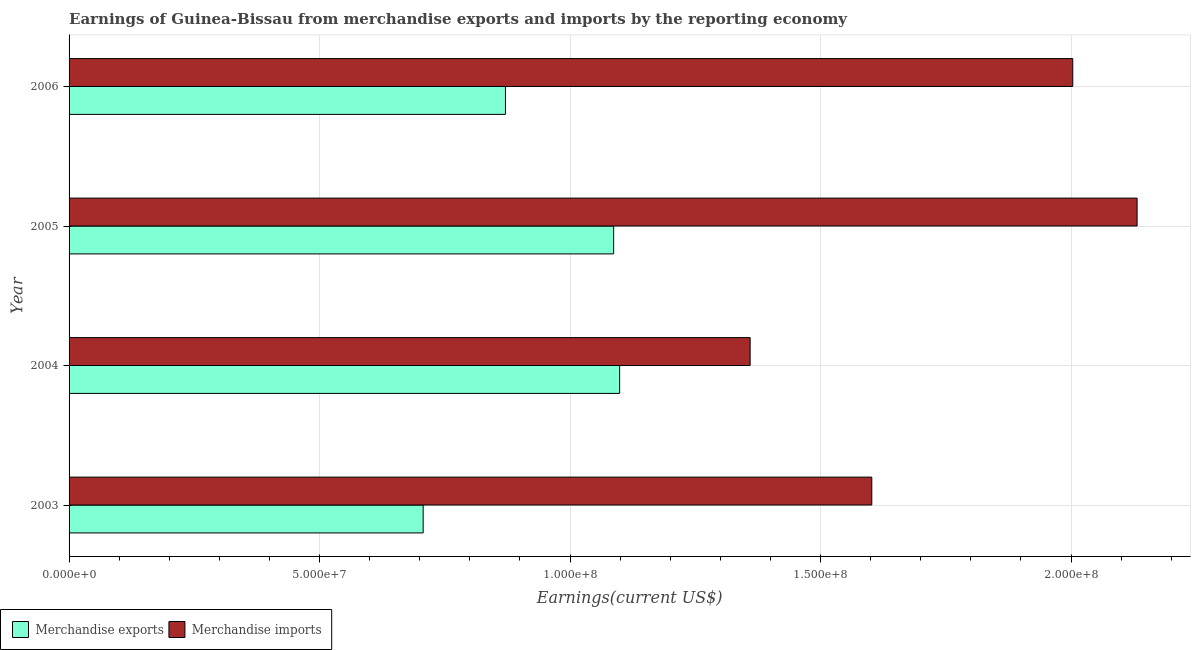How many different coloured bars are there?
Your response must be concise. 2. How many groups of bars are there?
Ensure brevity in your answer.  4. Are the number of bars per tick equal to the number of legend labels?
Ensure brevity in your answer.  Yes. How many bars are there on the 3rd tick from the bottom?
Ensure brevity in your answer.  2. What is the label of the 2nd group of bars from the top?
Ensure brevity in your answer.  2005. What is the earnings from merchandise imports in 2005?
Provide a short and direct response. 2.13e+08. Across all years, what is the maximum earnings from merchandise imports?
Your answer should be compact. 2.13e+08. Across all years, what is the minimum earnings from merchandise imports?
Your response must be concise. 1.36e+08. In which year was the earnings from merchandise imports minimum?
Ensure brevity in your answer.  2004. What is the total earnings from merchandise imports in the graph?
Provide a succinct answer. 7.10e+08. What is the difference between the earnings from merchandise exports in 2004 and that in 2005?
Give a very brief answer. 1.20e+06. What is the difference between the earnings from merchandise exports in 2004 and the earnings from merchandise imports in 2005?
Give a very brief answer. -1.03e+08. What is the average earnings from merchandise imports per year?
Your response must be concise. 1.77e+08. In the year 2005, what is the difference between the earnings from merchandise imports and earnings from merchandise exports?
Provide a succinct answer. 1.04e+08. Is the earnings from merchandise exports in 2005 less than that in 2006?
Your answer should be very brief. No. What is the difference between the highest and the second highest earnings from merchandise imports?
Your response must be concise. 1.28e+07. What is the difference between the highest and the lowest earnings from merchandise exports?
Your answer should be compact. 3.92e+07. Is the sum of the earnings from merchandise imports in 2003 and 2005 greater than the maximum earnings from merchandise exports across all years?
Your answer should be very brief. Yes. What does the 2nd bar from the bottom in 2003 represents?
Your answer should be compact. Merchandise imports. How many bars are there?
Your answer should be very brief. 8. How many years are there in the graph?
Your answer should be very brief. 4. Are the values on the major ticks of X-axis written in scientific E-notation?
Provide a succinct answer. Yes. Does the graph contain any zero values?
Keep it short and to the point. No. Does the graph contain grids?
Your answer should be compact. Yes. How are the legend labels stacked?
Make the answer very short. Horizontal. What is the title of the graph?
Make the answer very short. Earnings of Guinea-Bissau from merchandise exports and imports by the reporting economy. Does "Non-solid fuel" appear as one of the legend labels in the graph?
Provide a short and direct response. No. What is the label or title of the X-axis?
Keep it short and to the point. Earnings(current US$). What is the Earnings(current US$) in Merchandise exports in 2003?
Provide a succinct answer. 7.07e+07. What is the Earnings(current US$) in Merchandise imports in 2003?
Your response must be concise. 1.60e+08. What is the Earnings(current US$) of Merchandise exports in 2004?
Your answer should be compact. 1.10e+08. What is the Earnings(current US$) in Merchandise imports in 2004?
Offer a terse response. 1.36e+08. What is the Earnings(current US$) of Merchandise exports in 2005?
Offer a terse response. 1.09e+08. What is the Earnings(current US$) in Merchandise imports in 2005?
Offer a very short reply. 2.13e+08. What is the Earnings(current US$) of Merchandise exports in 2006?
Your answer should be very brief. 8.71e+07. What is the Earnings(current US$) in Merchandise imports in 2006?
Offer a very short reply. 2.00e+08. Across all years, what is the maximum Earnings(current US$) of Merchandise exports?
Your response must be concise. 1.10e+08. Across all years, what is the maximum Earnings(current US$) of Merchandise imports?
Your answer should be very brief. 2.13e+08. Across all years, what is the minimum Earnings(current US$) in Merchandise exports?
Ensure brevity in your answer.  7.07e+07. Across all years, what is the minimum Earnings(current US$) in Merchandise imports?
Provide a short and direct response. 1.36e+08. What is the total Earnings(current US$) in Merchandise exports in the graph?
Make the answer very short. 3.76e+08. What is the total Earnings(current US$) in Merchandise imports in the graph?
Give a very brief answer. 7.10e+08. What is the difference between the Earnings(current US$) in Merchandise exports in 2003 and that in 2004?
Offer a terse response. -3.92e+07. What is the difference between the Earnings(current US$) of Merchandise imports in 2003 and that in 2004?
Your answer should be very brief. 2.43e+07. What is the difference between the Earnings(current US$) of Merchandise exports in 2003 and that in 2005?
Make the answer very short. -3.80e+07. What is the difference between the Earnings(current US$) of Merchandise imports in 2003 and that in 2005?
Ensure brevity in your answer.  -5.30e+07. What is the difference between the Earnings(current US$) of Merchandise exports in 2003 and that in 2006?
Provide a succinct answer. -1.64e+07. What is the difference between the Earnings(current US$) in Merchandise imports in 2003 and that in 2006?
Provide a succinct answer. -4.01e+07. What is the difference between the Earnings(current US$) of Merchandise exports in 2004 and that in 2005?
Your response must be concise. 1.20e+06. What is the difference between the Earnings(current US$) of Merchandise imports in 2004 and that in 2005?
Ensure brevity in your answer.  -7.72e+07. What is the difference between the Earnings(current US$) of Merchandise exports in 2004 and that in 2006?
Give a very brief answer. 2.28e+07. What is the difference between the Earnings(current US$) of Merchandise imports in 2004 and that in 2006?
Keep it short and to the point. -6.44e+07. What is the difference between the Earnings(current US$) of Merchandise exports in 2005 and that in 2006?
Keep it short and to the point. 2.16e+07. What is the difference between the Earnings(current US$) in Merchandise imports in 2005 and that in 2006?
Offer a very short reply. 1.28e+07. What is the difference between the Earnings(current US$) of Merchandise exports in 2003 and the Earnings(current US$) of Merchandise imports in 2004?
Your response must be concise. -6.53e+07. What is the difference between the Earnings(current US$) in Merchandise exports in 2003 and the Earnings(current US$) in Merchandise imports in 2005?
Ensure brevity in your answer.  -1.43e+08. What is the difference between the Earnings(current US$) in Merchandise exports in 2003 and the Earnings(current US$) in Merchandise imports in 2006?
Your answer should be compact. -1.30e+08. What is the difference between the Earnings(current US$) of Merchandise exports in 2004 and the Earnings(current US$) of Merchandise imports in 2005?
Your answer should be very brief. -1.03e+08. What is the difference between the Earnings(current US$) in Merchandise exports in 2004 and the Earnings(current US$) in Merchandise imports in 2006?
Provide a short and direct response. -9.04e+07. What is the difference between the Earnings(current US$) of Merchandise exports in 2005 and the Earnings(current US$) of Merchandise imports in 2006?
Make the answer very short. -9.16e+07. What is the average Earnings(current US$) of Merchandise exports per year?
Provide a succinct answer. 9.41e+07. What is the average Earnings(current US$) of Merchandise imports per year?
Offer a very short reply. 1.77e+08. In the year 2003, what is the difference between the Earnings(current US$) of Merchandise exports and Earnings(current US$) of Merchandise imports?
Provide a succinct answer. -8.95e+07. In the year 2004, what is the difference between the Earnings(current US$) of Merchandise exports and Earnings(current US$) of Merchandise imports?
Your response must be concise. -2.60e+07. In the year 2005, what is the difference between the Earnings(current US$) of Merchandise exports and Earnings(current US$) of Merchandise imports?
Keep it short and to the point. -1.04e+08. In the year 2006, what is the difference between the Earnings(current US$) of Merchandise exports and Earnings(current US$) of Merchandise imports?
Keep it short and to the point. -1.13e+08. What is the ratio of the Earnings(current US$) in Merchandise exports in 2003 to that in 2004?
Your answer should be very brief. 0.64. What is the ratio of the Earnings(current US$) of Merchandise imports in 2003 to that in 2004?
Your answer should be compact. 1.18. What is the ratio of the Earnings(current US$) of Merchandise exports in 2003 to that in 2005?
Keep it short and to the point. 0.65. What is the ratio of the Earnings(current US$) of Merchandise imports in 2003 to that in 2005?
Your answer should be compact. 0.75. What is the ratio of the Earnings(current US$) in Merchandise exports in 2003 to that in 2006?
Your answer should be compact. 0.81. What is the ratio of the Earnings(current US$) of Merchandise imports in 2003 to that in 2006?
Keep it short and to the point. 0.8. What is the ratio of the Earnings(current US$) of Merchandise imports in 2004 to that in 2005?
Provide a short and direct response. 0.64. What is the ratio of the Earnings(current US$) of Merchandise exports in 2004 to that in 2006?
Provide a short and direct response. 1.26. What is the ratio of the Earnings(current US$) of Merchandise imports in 2004 to that in 2006?
Your response must be concise. 0.68. What is the ratio of the Earnings(current US$) in Merchandise exports in 2005 to that in 2006?
Your answer should be very brief. 1.25. What is the ratio of the Earnings(current US$) of Merchandise imports in 2005 to that in 2006?
Ensure brevity in your answer.  1.06. What is the difference between the highest and the second highest Earnings(current US$) of Merchandise exports?
Your response must be concise. 1.20e+06. What is the difference between the highest and the second highest Earnings(current US$) in Merchandise imports?
Make the answer very short. 1.28e+07. What is the difference between the highest and the lowest Earnings(current US$) of Merchandise exports?
Your answer should be very brief. 3.92e+07. What is the difference between the highest and the lowest Earnings(current US$) in Merchandise imports?
Your answer should be very brief. 7.72e+07. 